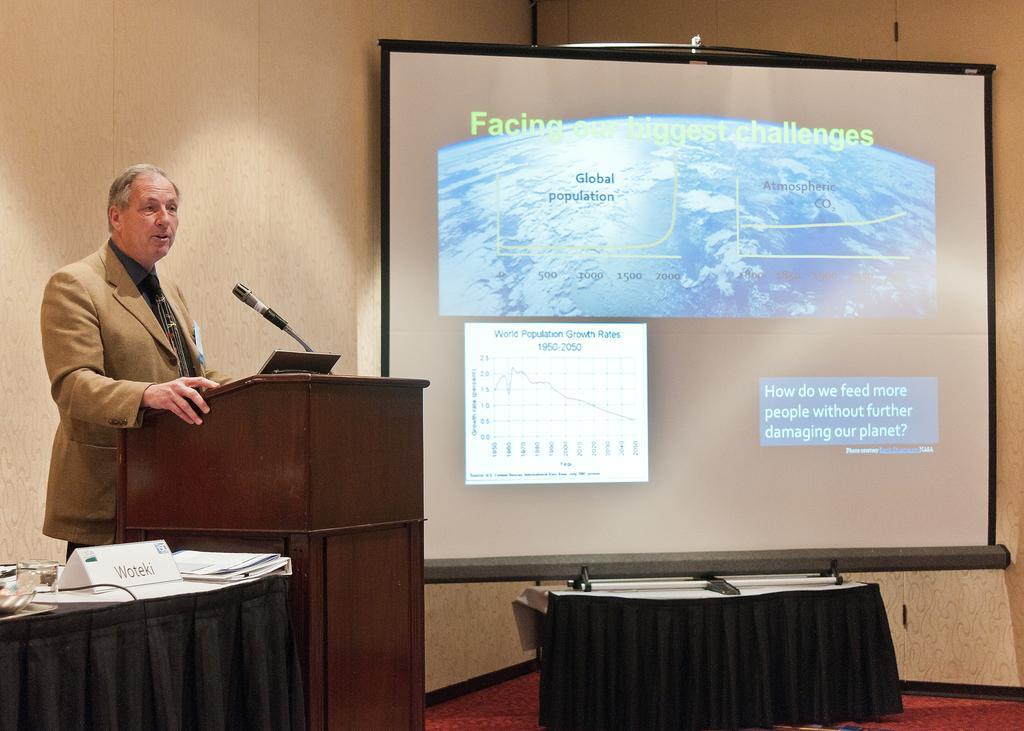Could you give a brief overview of what you see in this image? In this picture we can see a man is standing behind the podium and on the podium there is a microphone with stand. On the left side of the people there is a table and on the table there is a name board, papers and other things. On the right side of the people there is a projector screen and a wall. 